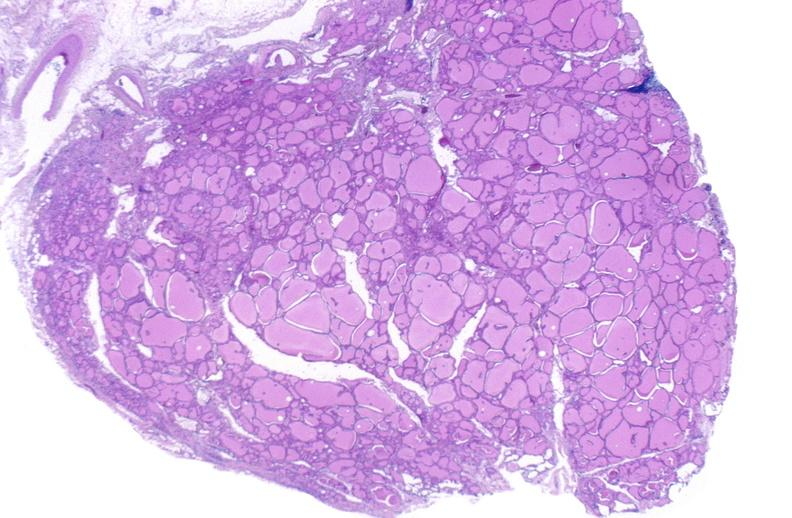does lesion of myocytolysis show thyroid gland, normal?
Answer the question using a single word or phrase. No 